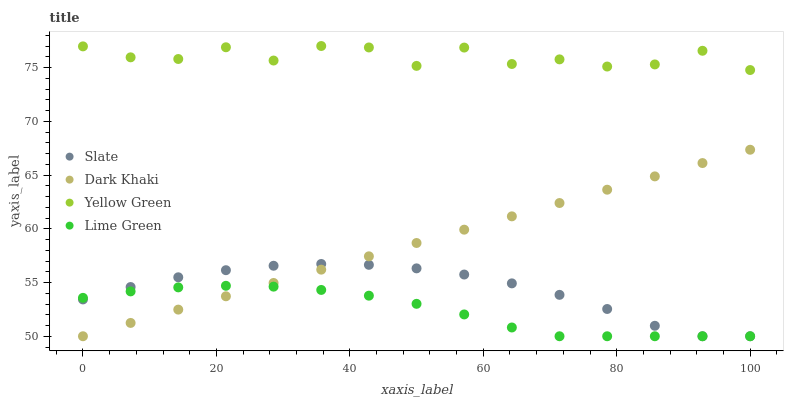Does Lime Green have the minimum area under the curve?
Answer yes or no. Yes. Does Yellow Green have the maximum area under the curve?
Answer yes or no. Yes. Does Slate have the minimum area under the curve?
Answer yes or no. No. Does Slate have the maximum area under the curve?
Answer yes or no. No. Is Dark Khaki the smoothest?
Answer yes or no. Yes. Is Yellow Green the roughest?
Answer yes or no. Yes. Is Slate the smoothest?
Answer yes or no. No. Is Slate the roughest?
Answer yes or no. No. Does Dark Khaki have the lowest value?
Answer yes or no. Yes. Does Yellow Green have the lowest value?
Answer yes or no. No. Does Yellow Green have the highest value?
Answer yes or no. Yes. Does Slate have the highest value?
Answer yes or no. No. Is Lime Green less than Yellow Green?
Answer yes or no. Yes. Is Yellow Green greater than Lime Green?
Answer yes or no. Yes. Does Slate intersect Dark Khaki?
Answer yes or no. Yes. Is Slate less than Dark Khaki?
Answer yes or no. No. Is Slate greater than Dark Khaki?
Answer yes or no. No. Does Lime Green intersect Yellow Green?
Answer yes or no. No. 